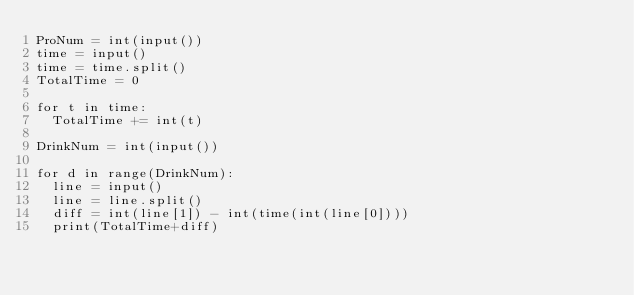Convert code to text. <code><loc_0><loc_0><loc_500><loc_500><_Python_>ProNum = int(input())
time = input()
time = time.split()
TotalTime = 0

for t in time:
  TotalTime += int(t)
                  
DrinkNum = int(input())

for d in range(DrinkNum):
  line = input()
  line = line.split()
  diff = int(line[1]) - int(time(int(line[0])))
  print(TotalTime+diff)
</code> 